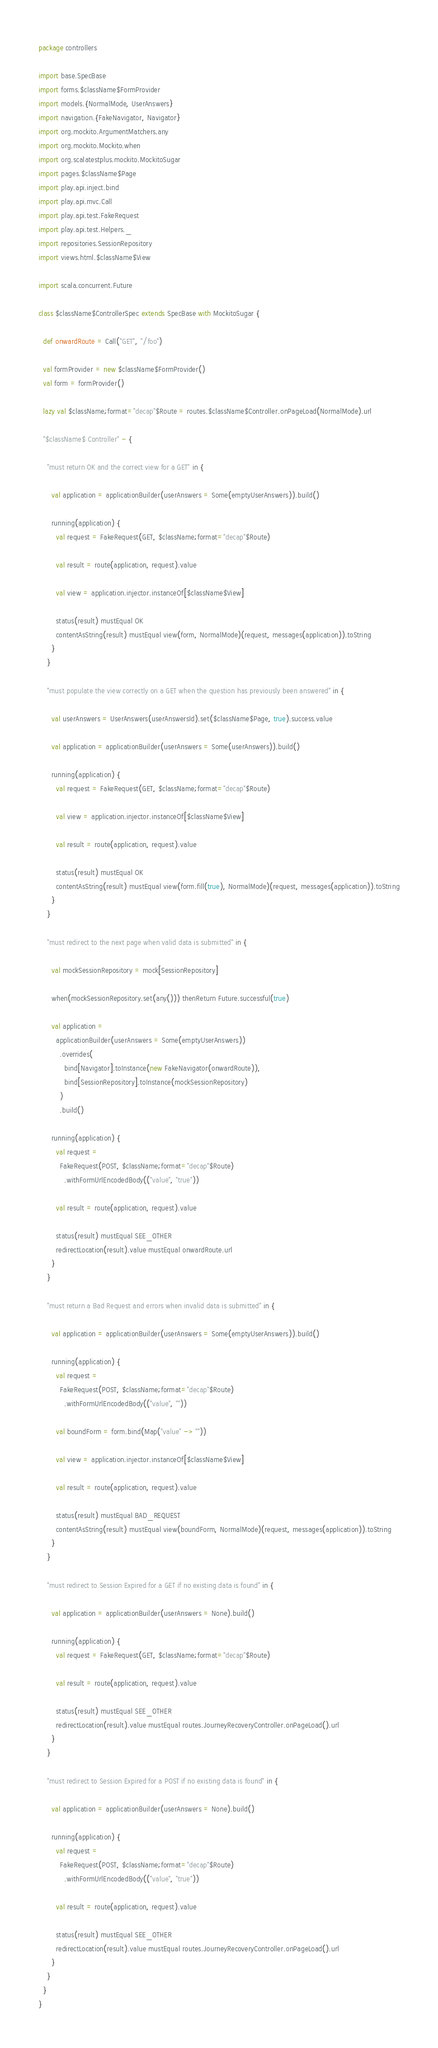<code> <loc_0><loc_0><loc_500><loc_500><_Scala_>package controllers

import base.SpecBase
import forms.$className$FormProvider
import models.{NormalMode, UserAnswers}
import navigation.{FakeNavigator, Navigator}
import org.mockito.ArgumentMatchers.any
import org.mockito.Mockito.when
import org.scalatestplus.mockito.MockitoSugar
import pages.$className$Page
import play.api.inject.bind
import play.api.mvc.Call
import play.api.test.FakeRequest
import play.api.test.Helpers._
import repositories.SessionRepository
import views.html.$className$View

import scala.concurrent.Future

class $className$ControllerSpec extends SpecBase with MockitoSugar {

  def onwardRoute = Call("GET", "/foo")

  val formProvider = new $className$FormProvider()
  val form = formProvider()

  lazy val $className;format="decap"$Route = routes.$className$Controller.onPageLoad(NormalMode).url

  "$className$ Controller" - {

    "must return OK and the correct view for a GET" in {

      val application = applicationBuilder(userAnswers = Some(emptyUserAnswers)).build()

      running(application) {
        val request = FakeRequest(GET, $className;format="decap"$Route)

        val result = route(application, request).value

        val view = application.injector.instanceOf[$className$View]

        status(result) mustEqual OK
        contentAsString(result) mustEqual view(form, NormalMode)(request, messages(application)).toString
      }
    }

    "must populate the view correctly on a GET when the question has previously been answered" in {

      val userAnswers = UserAnswers(userAnswersId).set($className$Page, true).success.value

      val application = applicationBuilder(userAnswers = Some(userAnswers)).build()

      running(application) {
        val request = FakeRequest(GET, $className;format="decap"$Route)

        val view = application.injector.instanceOf[$className$View]

        val result = route(application, request).value

        status(result) mustEqual OK
        contentAsString(result) mustEqual view(form.fill(true), NormalMode)(request, messages(application)).toString
      }
    }

    "must redirect to the next page when valid data is submitted" in {

      val mockSessionRepository = mock[SessionRepository]

      when(mockSessionRepository.set(any())) thenReturn Future.successful(true)

      val application =
        applicationBuilder(userAnswers = Some(emptyUserAnswers))
          .overrides(
            bind[Navigator].toInstance(new FakeNavigator(onwardRoute)),
            bind[SessionRepository].toInstance(mockSessionRepository)
          )
          .build()

      running(application) {
        val request =
          FakeRequest(POST, $className;format="decap"$Route)
            .withFormUrlEncodedBody(("value", "true"))

        val result = route(application, request).value

        status(result) mustEqual SEE_OTHER
        redirectLocation(result).value mustEqual onwardRoute.url
      }
    }

    "must return a Bad Request and errors when invalid data is submitted" in {

      val application = applicationBuilder(userAnswers = Some(emptyUserAnswers)).build()

      running(application) {
        val request =
          FakeRequest(POST, $className;format="decap"$Route)
            .withFormUrlEncodedBody(("value", ""))

        val boundForm = form.bind(Map("value" -> ""))

        val view = application.injector.instanceOf[$className$View]

        val result = route(application, request).value

        status(result) mustEqual BAD_REQUEST
        contentAsString(result) mustEqual view(boundForm, NormalMode)(request, messages(application)).toString
      }
    }

    "must redirect to Session Expired for a GET if no existing data is found" in {

      val application = applicationBuilder(userAnswers = None).build()

      running(application) {
        val request = FakeRequest(GET, $className;format="decap"$Route)

        val result = route(application, request).value

        status(result) mustEqual SEE_OTHER
        redirectLocation(result).value mustEqual routes.JourneyRecoveryController.onPageLoad().url
      }
    }

    "must redirect to Session Expired for a POST if no existing data is found" in {

      val application = applicationBuilder(userAnswers = None).build()

      running(application) {
        val request =
          FakeRequest(POST, $className;format="decap"$Route)
            .withFormUrlEncodedBody(("value", "true"))

        val result = route(application, request).value

        status(result) mustEqual SEE_OTHER
        redirectLocation(result).value mustEqual routes.JourneyRecoveryController.onPageLoad().url
      }
    }
  }
}
</code> 